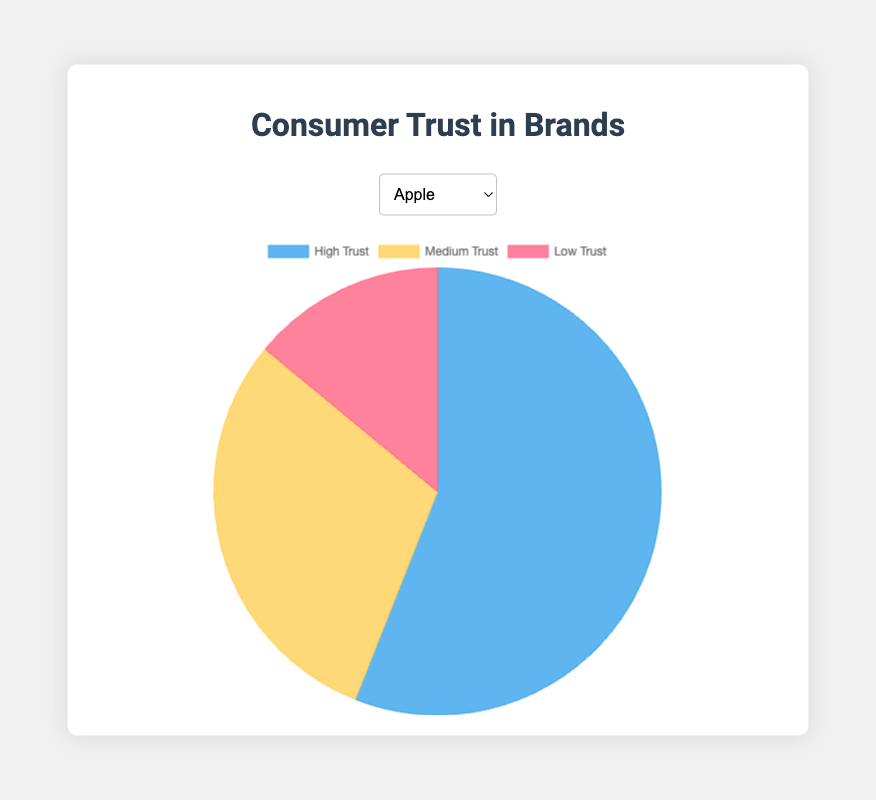What is the proportion of high trust for Apple? The pie chart for Apple shows that the high trust segment is the largest portion. From the dataset, we know that the high trust proportion for Apple is 0.56, or 56%.
Answer: 56% Which brand has the highest proportion of high trust? By comparing the high trust segments of the pie charts for all brands, Toyota's chart has the largest high trust segment. From the dataset, Toyota has a high trust proportion of 0.60, which is the highest.
Answer: Toyota Compare the medium trust levels between Nike and Samsung. Which is greater and by how much? Referring to the pie charts, Nike has a medium trust proportion of 0.40, and Samsung has a medium trust proportion of 0.36. The difference is 0.40 - 0.36 = 0.04, or 4%.
Answer: Nike by 4% What is the combined proportion of medium and low trust for Coca-Cola? From the pie chart, the medium trust proportion for Coca-Cola is 0.35 and the low trust proportion is 0.15. Adding these together: 0.35 + 0.15 = 0.50, or 50%.
Answer: 50% Out of the displayed brands, which one has the smallest low trust proportion, and what is that proportion? By examining the low trust segments of the pie charts, Apple has the smallest low trust proportion of 0.14, or 14%.
Answer: Apple, 14% Which brand's pie chart would represent the most balanced trust distribution if no segment exceeded 50%? By examining all pie charts, Nike has no segment exceeding 50%. The high trust is 0.45, medium trust is 0.40, and low trust is 0.15.
Answer: Nike If you combined the low trust proportions of all brands, what is the total percentage? Adding the low trust proportions: Apple (0.14), Samsung (0.16), Nike (0.15), Coca-Cola (0.15), and Toyota (0.15). The sum is 0.14 + 0.16 + 0.15 + 0.15 + 0.15 = 0.75, or 75%.
Answer: 75% What is the difference in high trust proportions between Toyota and Coca-Cola? From the pie charts, Toyota has a high trust proportion of 0.60 and Coca-Cola has 0.50. The difference is 0.60 - 0.50 = 0.10, or 10%.
Answer: 10% Identify the brand whose medium and low trust proportions combined are below 50%. By adding the medium and low trust proportions: Apple (0.30 + 0.14 = 0.44), Samsung (0.36 + 0.16 = 0.52), Nike (0.40 + 0.15 = 0.55), Coca-Cola (0.35 + 0.15 = 0.50), and Toyota (0.25 + 0.15 = 0.40). The only brand below 50% is Toyota with 0.40, or 40%.
Answer: Toyota 